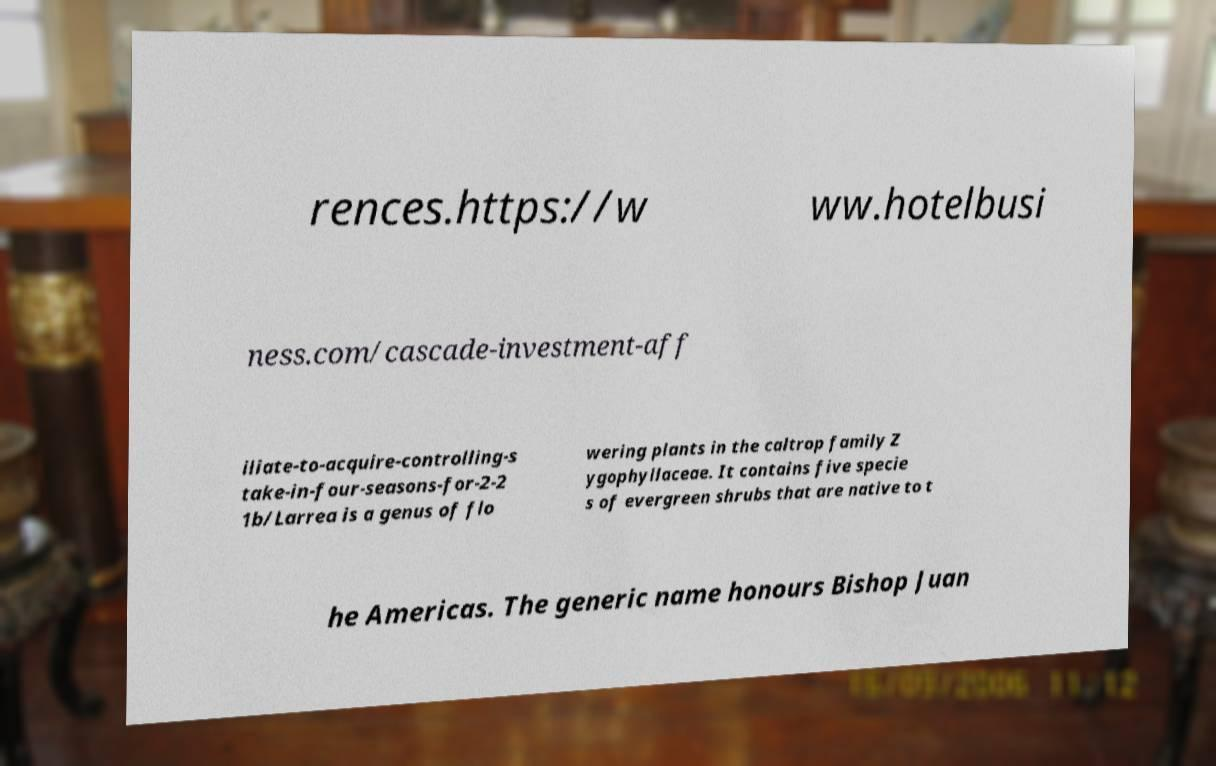Can you accurately transcribe the text from the provided image for me? rences.https://w ww.hotelbusi ness.com/cascade-investment-aff iliate-to-acquire-controlling-s take-in-four-seasons-for-2-2 1b/Larrea is a genus of flo wering plants in the caltrop family Z ygophyllaceae. It contains five specie s of evergreen shrubs that are native to t he Americas. The generic name honours Bishop Juan 